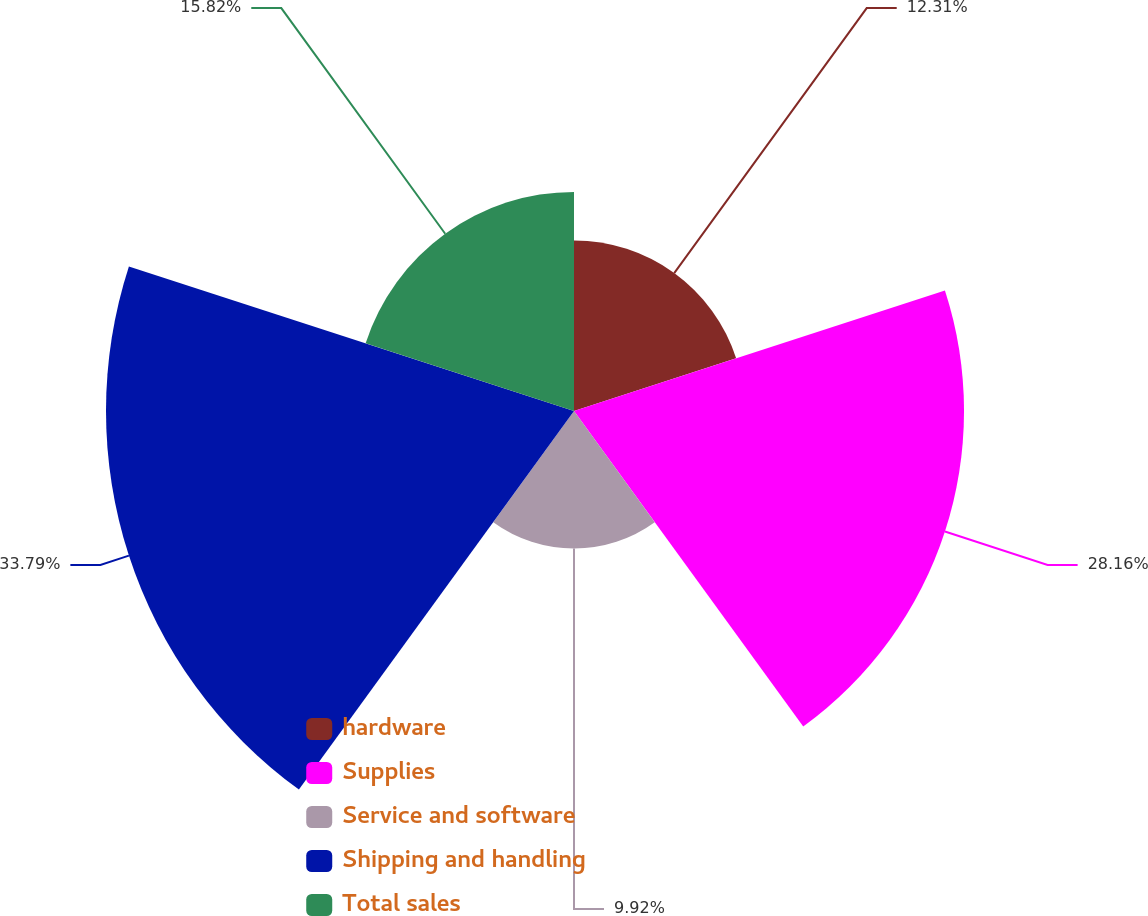<chart> <loc_0><loc_0><loc_500><loc_500><pie_chart><fcel>hardware<fcel>Supplies<fcel>Service and software<fcel>Shipping and handling<fcel>Total sales<nl><fcel>12.31%<fcel>28.16%<fcel>9.92%<fcel>33.79%<fcel>15.82%<nl></chart> 